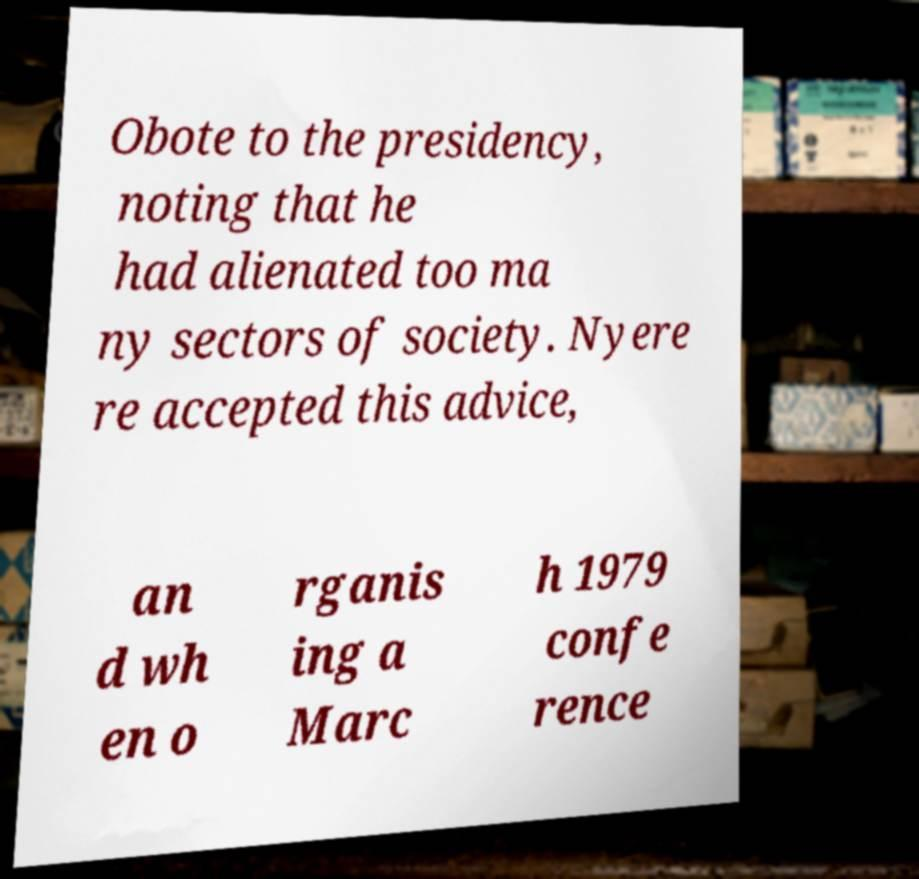What messages or text are displayed in this image? I need them in a readable, typed format. Obote to the presidency, noting that he had alienated too ma ny sectors of society. Nyere re accepted this advice, an d wh en o rganis ing a Marc h 1979 confe rence 